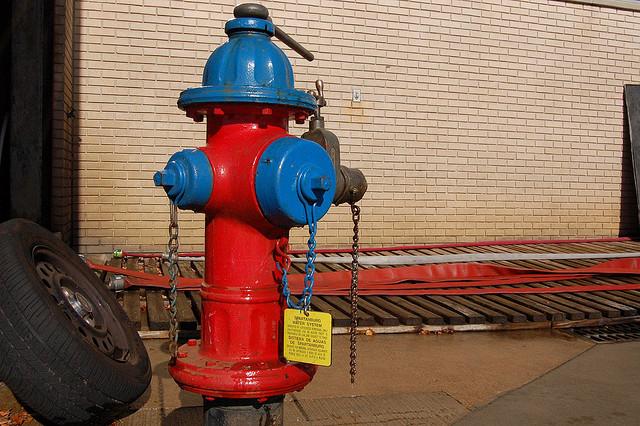What is behind the hydrant?
Answer briefly. Tire. What is next to the hydrant?
Answer briefly. Tire. Is the hydrant ready to be used?
Keep it brief. Yes. What colors is the fire hydrant?
Be succinct. Red and blue. 